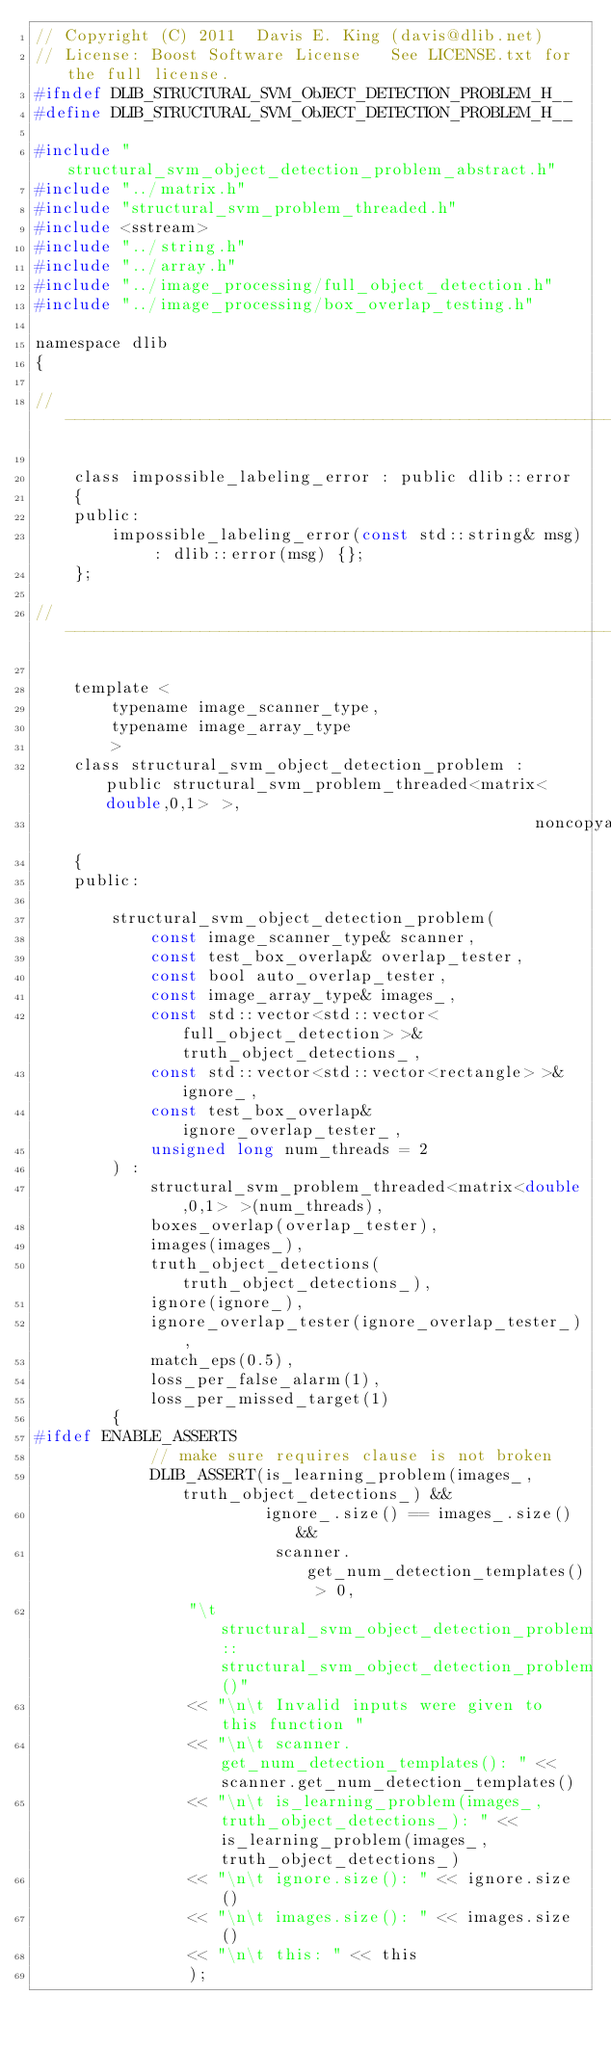Convert code to text. <code><loc_0><loc_0><loc_500><loc_500><_C_>// Copyright (C) 2011  Davis E. King (davis@dlib.net)
// License: Boost Software License   See LICENSE.txt for the full license.
#ifndef DLIB_STRUCTURAL_SVM_ObJECT_DETECTION_PROBLEM_H__
#define DLIB_STRUCTURAL_SVM_ObJECT_DETECTION_PROBLEM_H__

#include "structural_svm_object_detection_problem_abstract.h"
#include "../matrix.h"
#include "structural_svm_problem_threaded.h"
#include <sstream>
#include "../string.h"
#include "../array.h"
#include "../image_processing/full_object_detection.h"
#include "../image_processing/box_overlap_testing.h"

namespace dlib
{

// ----------------------------------------------------------------------------------------

    class impossible_labeling_error : public dlib::error 
    { 
    public: 
        impossible_labeling_error(const std::string& msg) : dlib::error(msg) {};
    };

// ----------------------------------------------------------------------------------------

    template <
        typename image_scanner_type,
        typename image_array_type 
        >
    class structural_svm_object_detection_problem : public structural_svm_problem_threaded<matrix<double,0,1> >,
                                                    noncopyable
    {
    public:

        structural_svm_object_detection_problem(
            const image_scanner_type& scanner,
            const test_box_overlap& overlap_tester,
            const bool auto_overlap_tester,
            const image_array_type& images_,
            const std::vector<std::vector<full_object_detection> >& truth_object_detections_,
            const std::vector<std::vector<rectangle> >& ignore_,
            const test_box_overlap& ignore_overlap_tester_,
            unsigned long num_threads = 2
        ) :
            structural_svm_problem_threaded<matrix<double,0,1> >(num_threads),
            boxes_overlap(overlap_tester),
            images(images_),
            truth_object_detections(truth_object_detections_),
            ignore(ignore_),
            ignore_overlap_tester(ignore_overlap_tester_),
            match_eps(0.5),
            loss_per_false_alarm(1),
            loss_per_missed_target(1)
        {
#ifdef ENABLE_ASSERTS
            // make sure requires clause is not broken
            DLIB_ASSERT(is_learning_problem(images_, truth_object_detections_) && 
                        ignore_.size() == images_.size() &&
                         scanner.get_num_detection_templates() > 0,
                "\t structural_svm_object_detection_problem::structural_svm_object_detection_problem()"
                << "\n\t Invalid inputs were given to this function "
                << "\n\t scanner.get_num_detection_templates(): " << scanner.get_num_detection_templates()
                << "\n\t is_learning_problem(images_,truth_object_detections_): " << is_learning_problem(images_,truth_object_detections_)
                << "\n\t ignore.size(): " << ignore.size() 
                << "\n\t images.size(): " << images.size() 
                << "\n\t this: " << this
                );</code> 